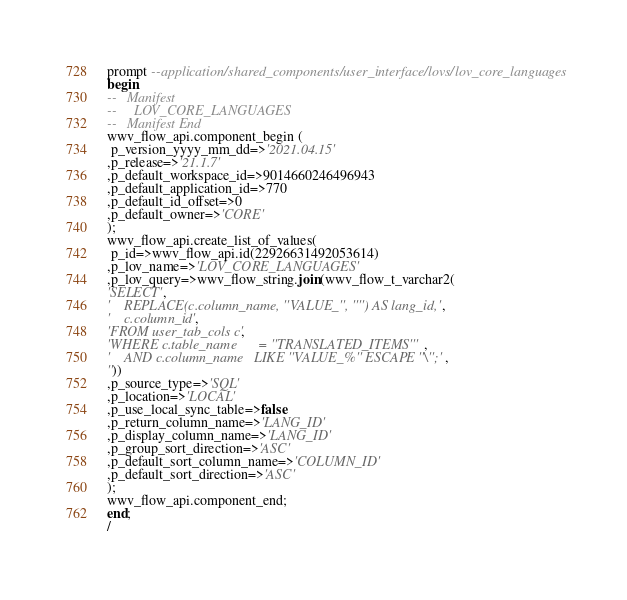Convert code to text. <code><loc_0><loc_0><loc_500><loc_500><_SQL_>prompt --application/shared_components/user_interface/lovs/lov_core_languages
begin
--   Manifest
--     LOV_CORE_LANGUAGES
--   Manifest End
wwv_flow_api.component_begin (
 p_version_yyyy_mm_dd=>'2021.04.15'
,p_release=>'21.1.7'
,p_default_workspace_id=>9014660246496943
,p_default_application_id=>770
,p_default_id_offset=>0
,p_default_owner=>'CORE'
);
wwv_flow_api.create_list_of_values(
 p_id=>wwv_flow_api.id(22926631492053614)
,p_lov_name=>'LOV_CORE_LANGUAGES'
,p_lov_query=>wwv_flow_string.join(wwv_flow_t_varchar2(
'SELECT',
'    REPLACE(c.column_name, ''VALUE_'', '''') AS lang_id,',
'    c.column_id',
'FROM user_tab_cols c',
'WHERE c.table_name      = ''TRANSLATED_ITEMS''',
'    AND c.column_name   LIKE ''VALUE_%'' ESCAPE ''\'';',
''))
,p_source_type=>'SQL'
,p_location=>'LOCAL'
,p_use_local_sync_table=>false
,p_return_column_name=>'LANG_ID'
,p_display_column_name=>'LANG_ID'
,p_group_sort_direction=>'ASC'
,p_default_sort_column_name=>'COLUMN_ID'
,p_default_sort_direction=>'ASC'
);
wwv_flow_api.component_end;
end;
/
</code> 